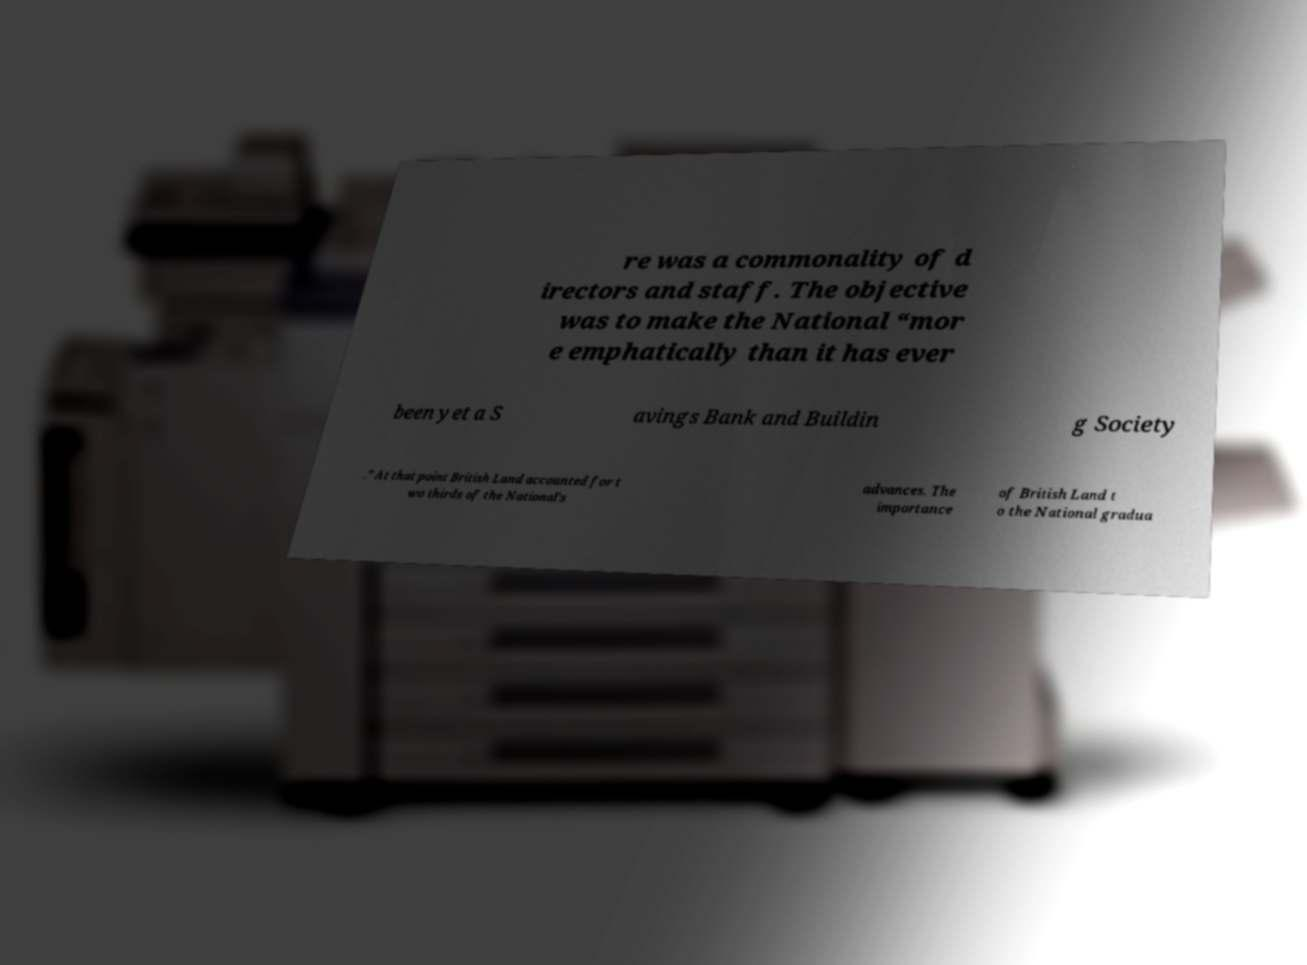Please identify and transcribe the text found in this image. re was a commonality of d irectors and staff. The objective was to make the National “mor e emphatically than it has ever been yet a S avings Bank and Buildin g Society .” At that point British Land accounted for t wo thirds of the National’s advances. The importance of British Land t o the National gradua 